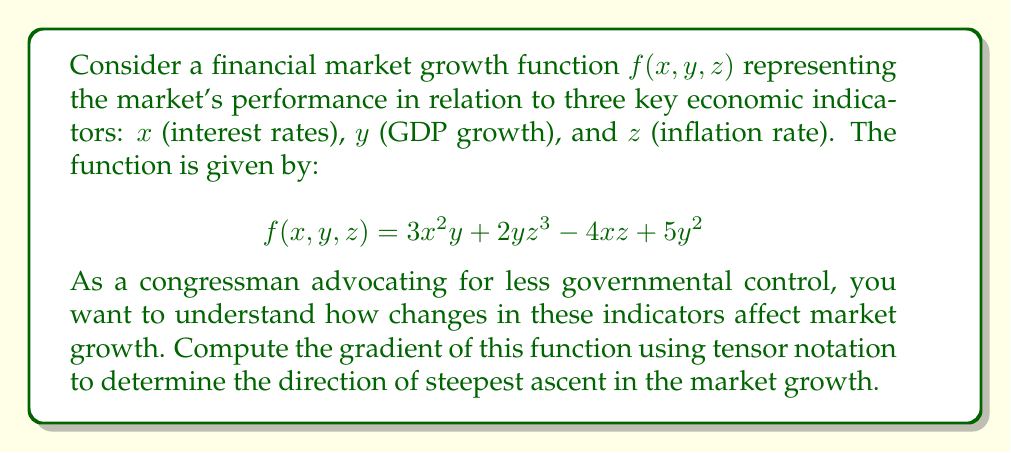Could you help me with this problem? To compute the gradient of the financial market growth function using tensor notation, we need to follow these steps:

1. Recall that the gradient in tensor notation is represented as:

   $$\nabla f = \frac{\partial f}{\partial x^i}$$

   where $x^i$ represents the components $(x, y, z)$ in our case.

2. Calculate the partial derivatives with respect to each variable:

   a) $\frac{\partial f}{\partial x} = 6xy - 4z$
   
   b) $\frac{\partial f}{\partial y} = 3x^2 + 2z^3 + 10y$
   
   c) $\frac{\partial f}{\partial z} = 6yz^2 - 4x$

3. Express the gradient in tensor notation:

   $$\nabla f = (6xy - 4z)\hat{i} + (3x^2 + 2z^3 + 10y)\hat{j} + (6yz^2 - 4x)\hat{k}$$

   where $\hat{i}$, $\hat{j}$, and $\hat{k}$ are unit vectors in the $x$, $y$, and $z$ directions, respectively.

4. This gradient represents the direction of steepest ascent in the market growth function, indicating how changes in interest rates, GDP growth, and inflation rate affect the market's performance most rapidly.
Answer: $$\nabla f = (6xy - 4z)\hat{i} + (3x^2 + 2z^3 + 10y)\hat{j} + (6yz^2 - 4x)\hat{k}$$ 